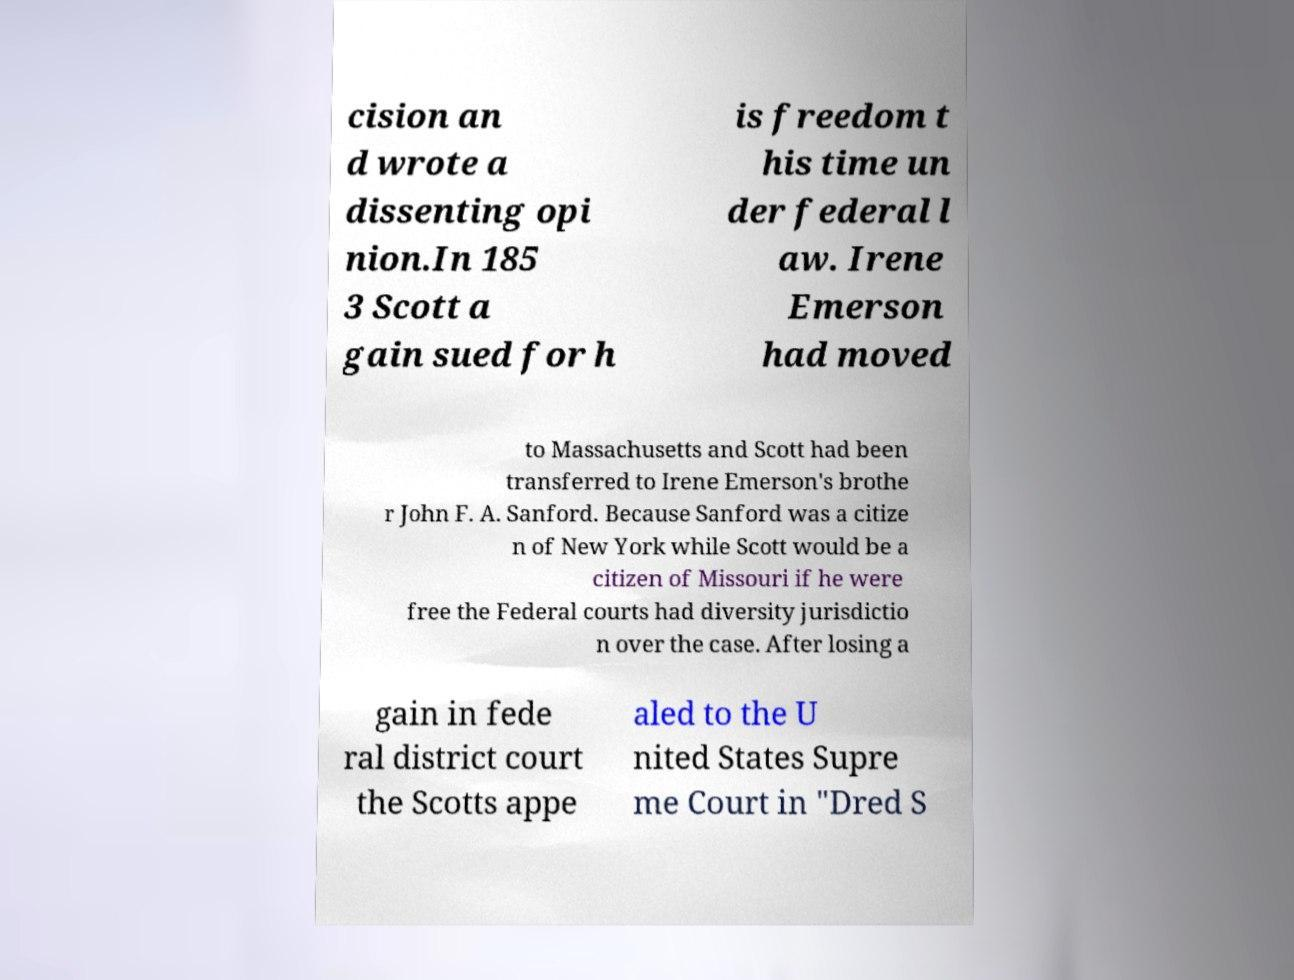Can you read and provide the text displayed in the image?This photo seems to have some interesting text. Can you extract and type it out for me? cision an d wrote a dissenting opi nion.In 185 3 Scott a gain sued for h is freedom t his time un der federal l aw. Irene Emerson had moved to Massachusetts and Scott had been transferred to Irene Emerson's brothe r John F. A. Sanford. Because Sanford was a citize n of New York while Scott would be a citizen of Missouri if he were free the Federal courts had diversity jurisdictio n over the case. After losing a gain in fede ral district court the Scotts appe aled to the U nited States Supre me Court in "Dred S 